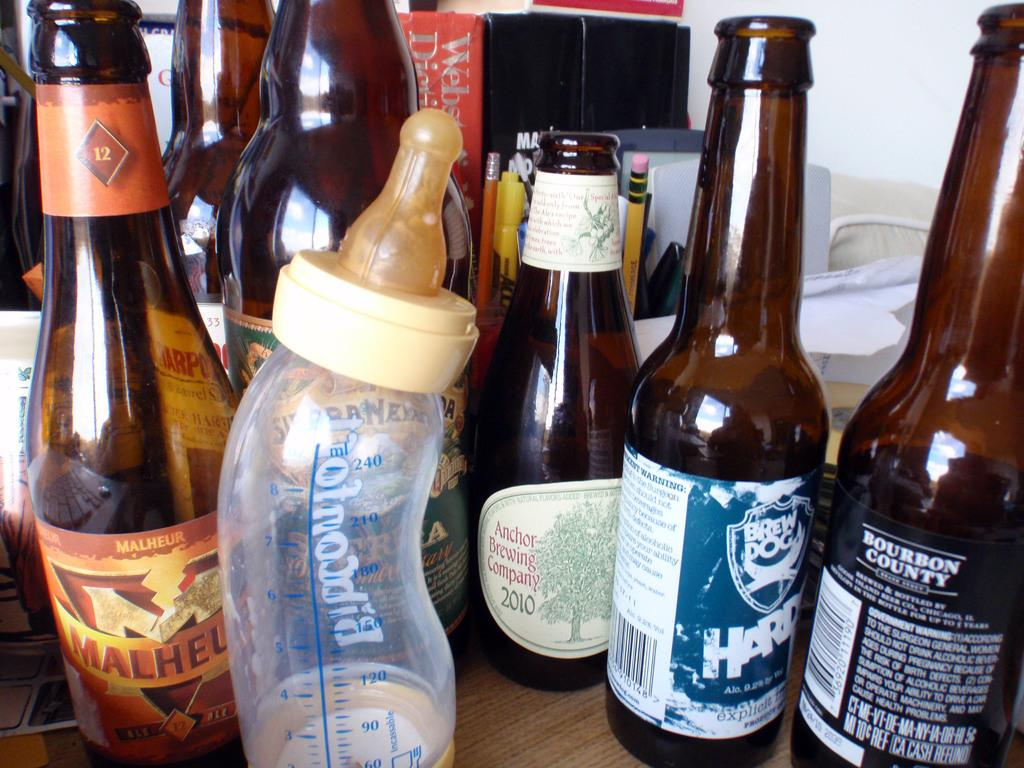<image>
Create a compact narrative representing the image presented. An infants bottle is left on a table  next to a bottle of Malheur 